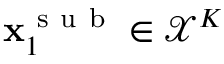Convert formula to latex. <formula><loc_0><loc_0><loc_500><loc_500>x _ { 1 } ^ { s u b } \in \mathcal { X } ^ { K }</formula> 